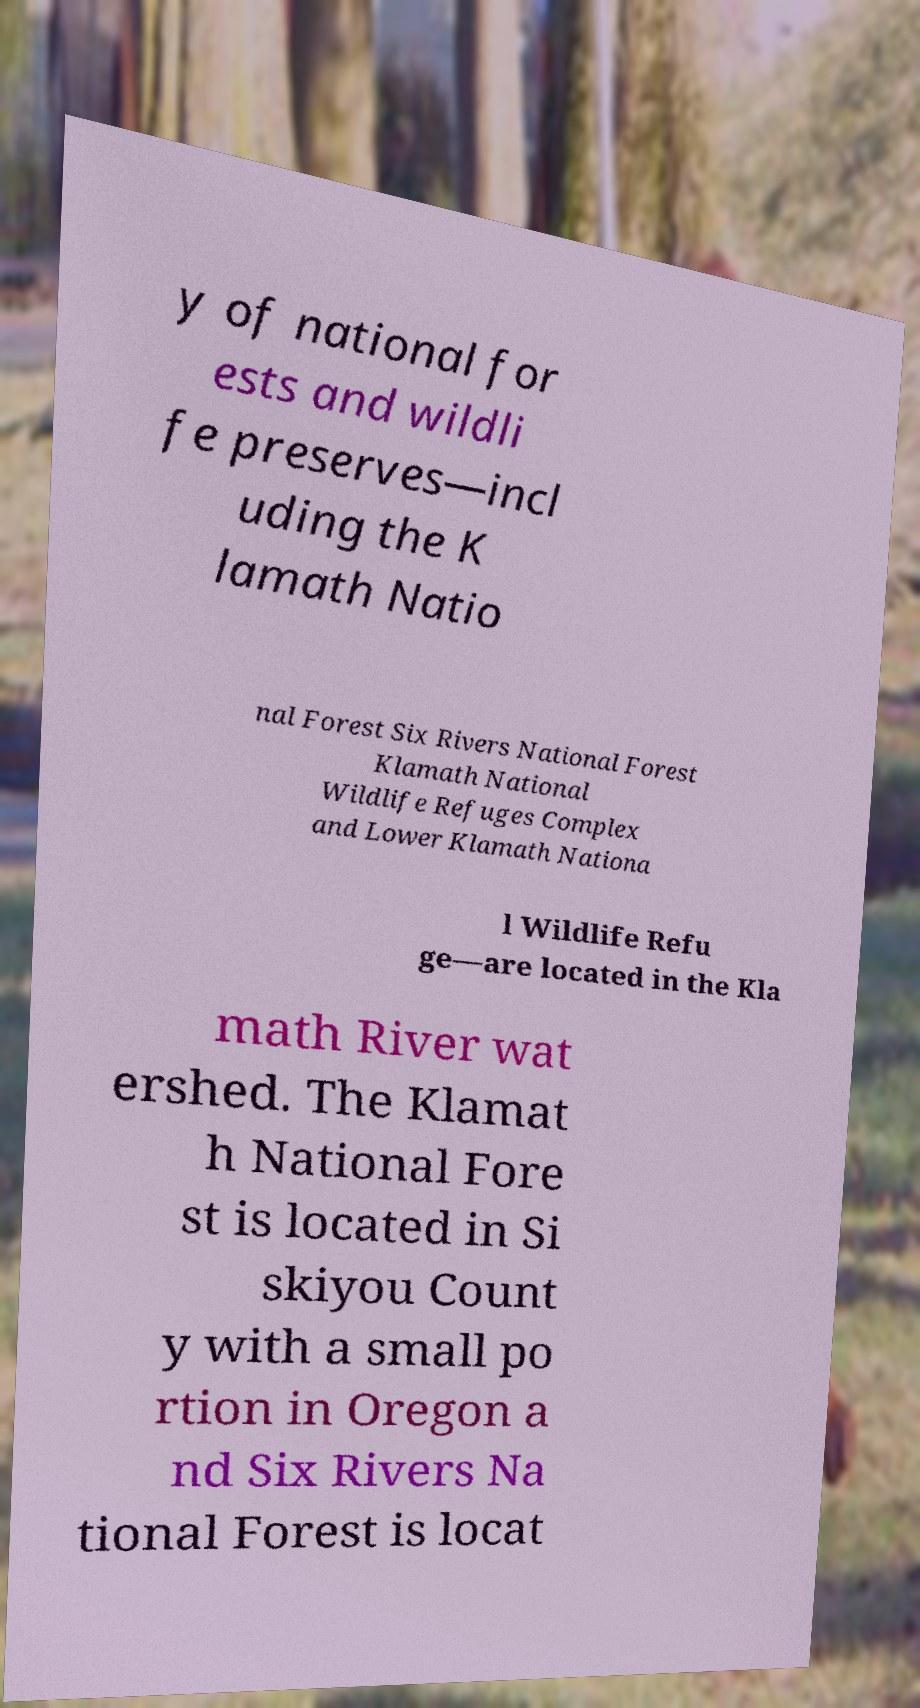Can you read and provide the text displayed in the image?This photo seems to have some interesting text. Can you extract and type it out for me? y of national for ests and wildli fe preserves—incl uding the K lamath Natio nal Forest Six Rivers National Forest Klamath National Wildlife Refuges Complex and Lower Klamath Nationa l Wildlife Refu ge—are located in the Kla math River wat ershed. The Klamat h National Fore st is located in Si skiyou Count y with a small po rtion in Oregon a nd Six Rivers Na tional Forest is locat 